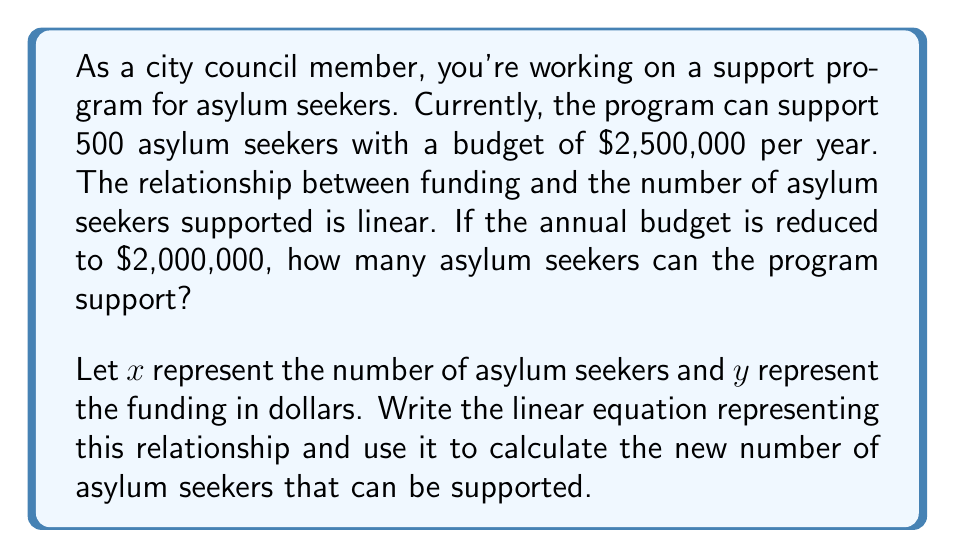Show me your answer to this math problem. To solve this problem, we'll follow these steps:

1) First, we need to find the linear equation that represents the relationship between funding and the number of asylum seekers supported.

   The general form of a linear equation is $y = mx + b$, where $m$ is the slope and $b$ is the y-intercept.

2) We can find the slope using the given information:
   
   $m = \frac{\text{change in y}}{\text{change in x}} = \frac{2,500,000 - 0}{500 - 0} = 5,000$

   This means it costs $5,000 per asylum seeker.

3) Now we can write the equation:

   $y = 5000x$

   Note that the y-intercept is 0, as when no asylum seekers are supported (x = 0), no funding is needed (y = 0).

4) To find how many asylum seekers can be supported with $2,000,000, we substitute y with 2,000,000:

   $2,000,000 = 5000x$

5) Solve for x:

   $x = \frac{2,000,000}{5000} = 400$

Therefore, with the reduced budget, the program can support 400 asylum seekers.
Answer: The program can support 400 asylum seekers with the reduced budget of $2,000,000. 